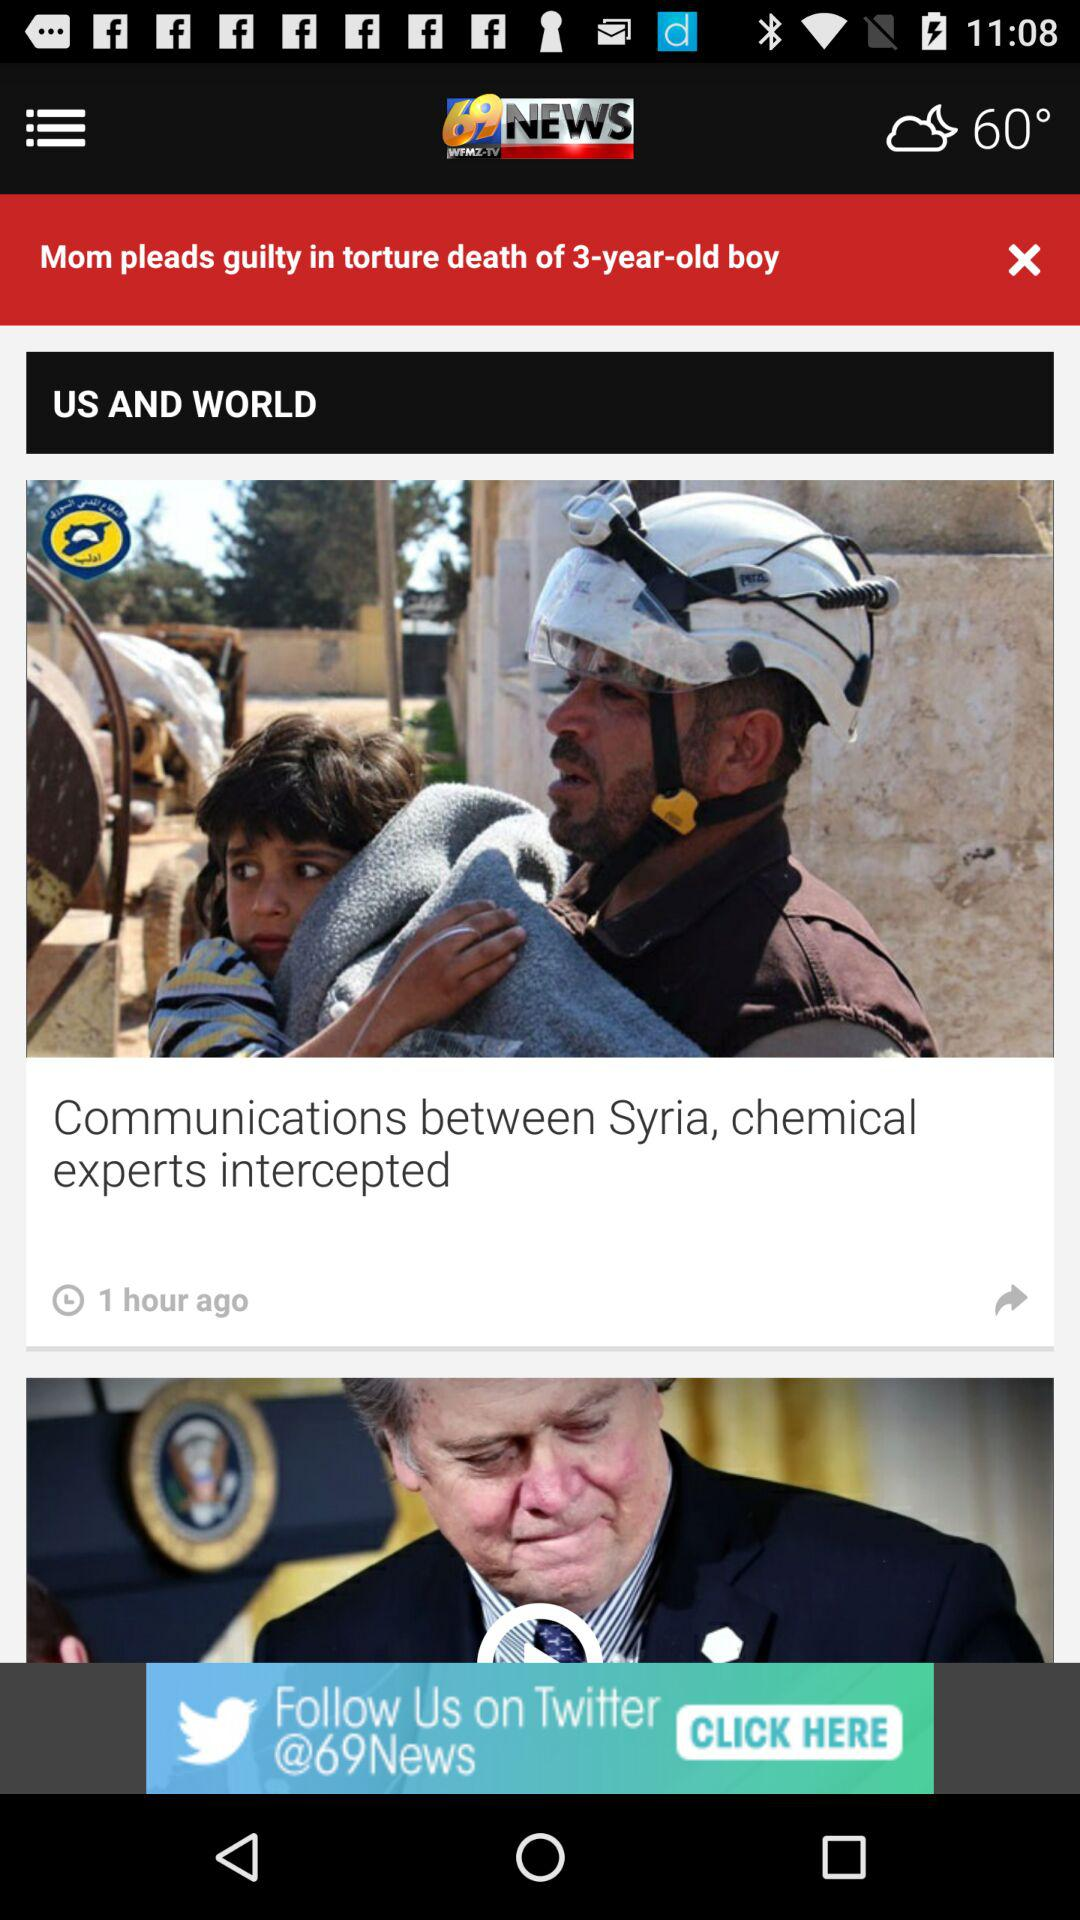What is the temperature? The temperature is 60°. 